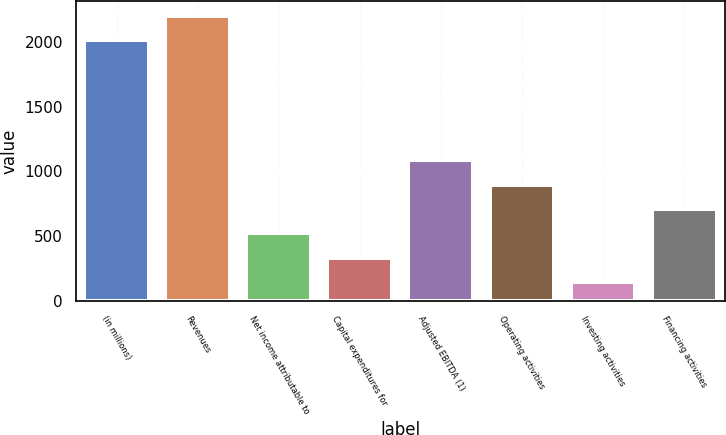<chart> <loc_0><loc_0><loc_500><loc_500><bar_chart><fcel>(in millions)<fcel>Revenues<fcel>Net income attributable to<fcel>Capital expenditures for<fcel>Adjusted EBITDA (1)<fcel>Operating activities<fcel>Investing activities<fcel>Financing activities<nl><fcel>2014<fcel>2201.5<fcel>522<fcel>334.5<fcel>1084.5<fcel>897<fcel>147<fcel>709.5<nl></chart> 